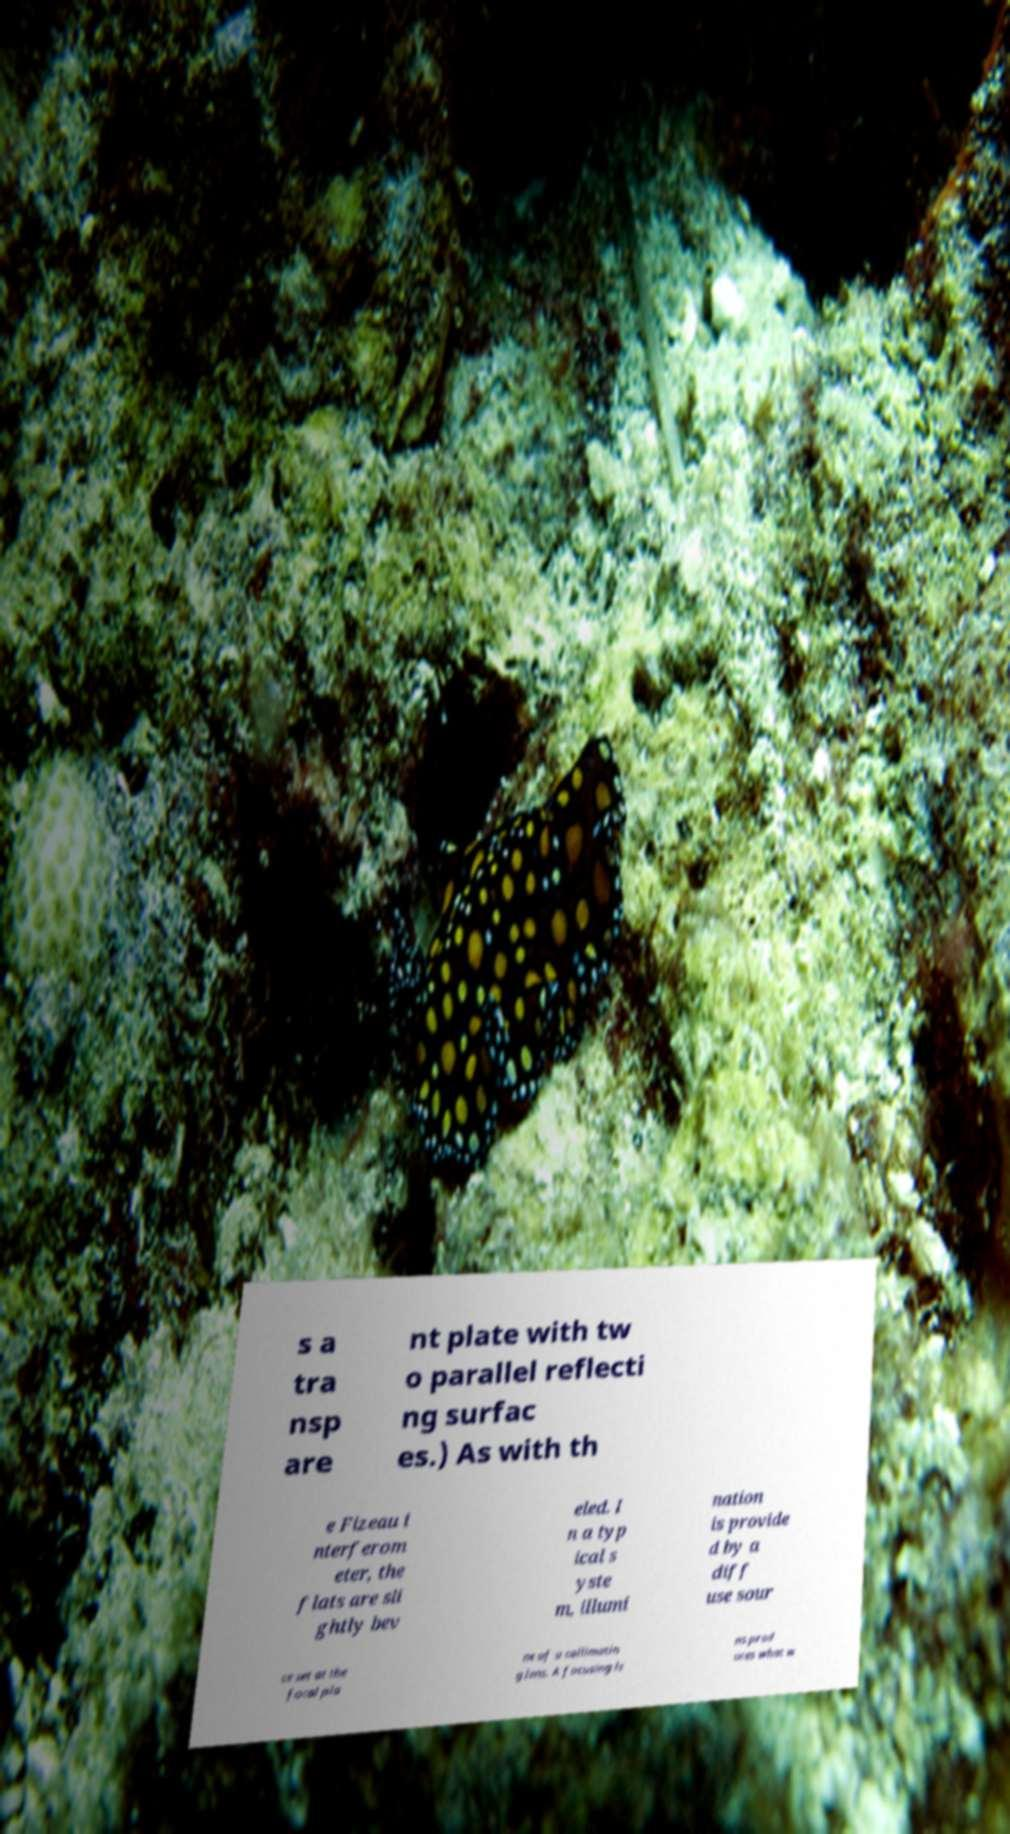Please read and relay the text visible in this image. What does it say? s a tra nsp are nt plate with tw o parallel reflecti ng surfac es.) As with th e Fizeau i nterferom eter, the flats are sli ghtly bev eled. I n a typ ical s yste m, illumi nation is provide d by a diff use sour ce set at the focal pla ne of a collimatin g lens. A focusing le ns prod uces what w 